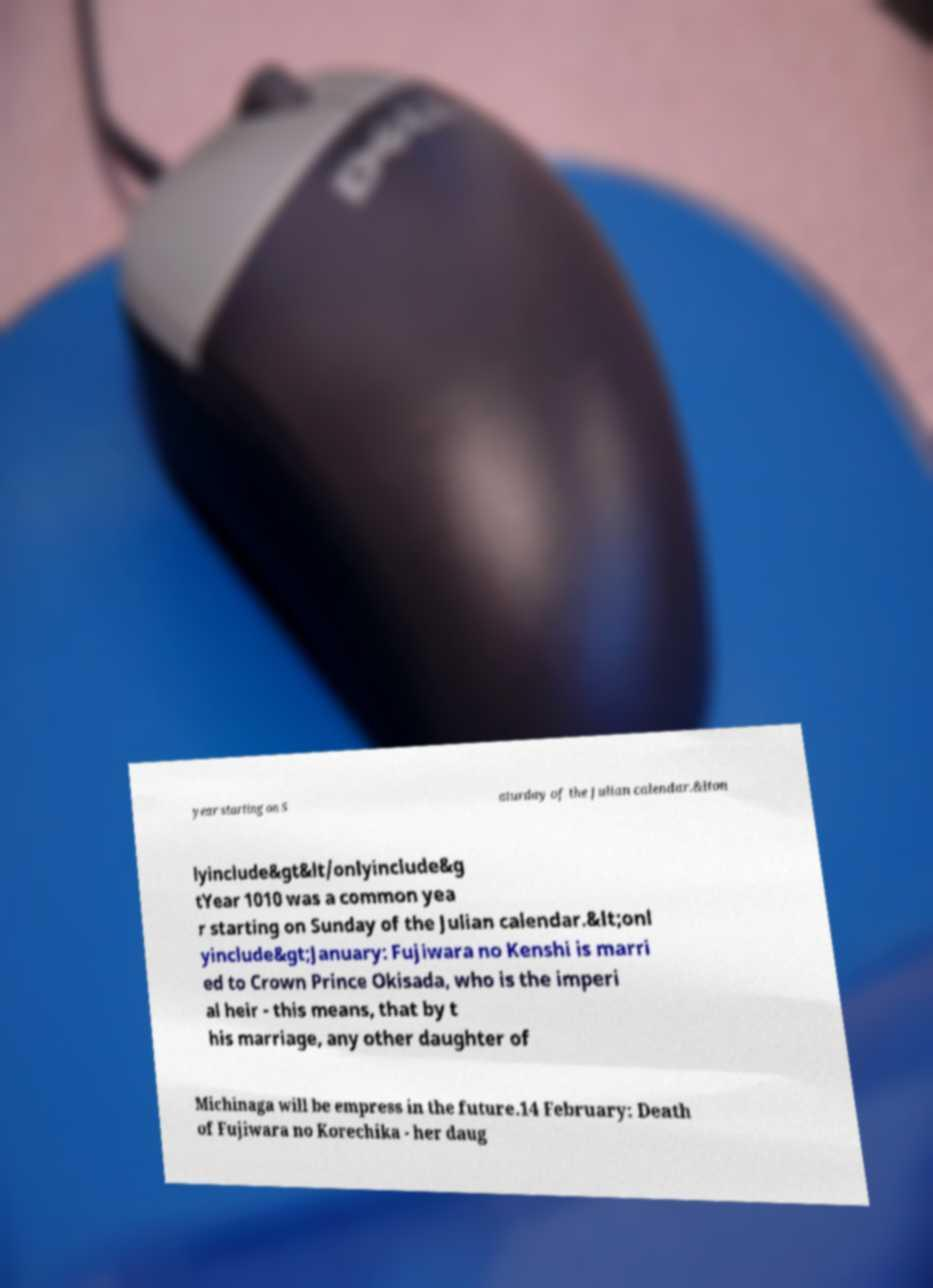Can you read and provide the text displayed in the image?This photo seems to have some interesting text. Can you extract and type it out for me? year starting on S aturday of the Julian calendar.&lton lyinclude&gt&lt/onlyinclude&g tYear 1010 was a common yea r starting on Sunday of the Julian calendar.&lt;onl yinclude&gt;January: Fujiwara no Kenshi is marri ed to Crown Prince Okisada, who is the imperi al heir - this means, that by t his marriage, any other daughter of Michinaga will be empress in the future.14 February: Death of Fujiwara no Korechika - her daug 